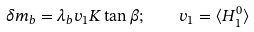Convert formula to latex. <formula><loc_0><loc_0><loc_500><loc_500>\delta m _ { b } = \lambda _ { b } v _ { 1 } K \tan { \beta } ; \quad v _ { 1 } = \langle H _ { 1 } ^ { 0 } \rangle</formula> 